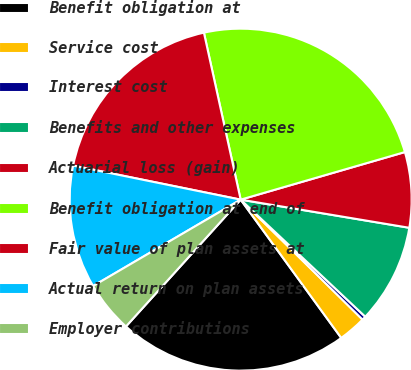<chart> <loc_0><loc_0><loc_500><loc_500><pie_chart><fcel>Benefit obligation at<fcel>Service cost<fcel>Interest cost<fcel>Benefits and other expenses<fcel>Actuarial loss (gain)<fcel>Benefit obligation at end of<fcel>Fair value of plan assets at<fcel>Actual return on plan assets<fcel>Employer contributions<nl><fcel>21.71%<fcel>2.62%<fcel>0.37%<fcel>9.37%<fcel>7.12%<fcel>23.96%<fcel>18.36%<fcel>11.62%<fcel>4.87%<nl></chart> 